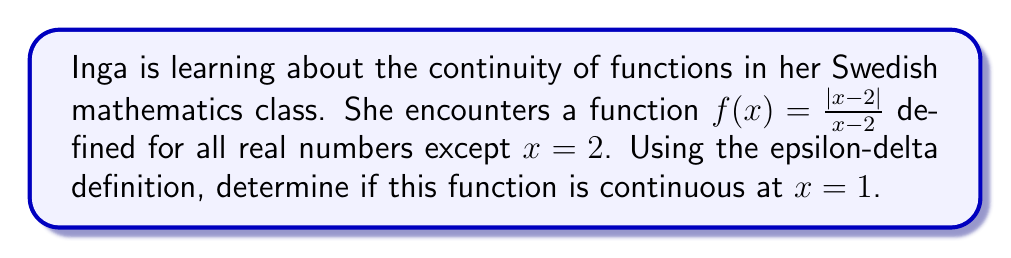What is the answer to this math problem? To prove continuity at $x=1$ using the epsilon-delta definition, we need to show that for every $\epsilon > 0$, there exists a $\delta > 0$ such that:

$|x - 1| < \delta \implies |f(x) - f(1)| < \epsilon$

Let's approach this step-by-step:

1) First, let's calculate $f(1)$:
   $f(1) = \frac{|1-2|}{1-2} = \frac{1}{-1} = -1$

2) Now, let's simplify $|f(x) - f(1)|$:
   $|f(x) - f(1)| = |\frac{|x-2|}{x-2} - (-1)|$
                  $= |\frac{|x-2|}{x-2} + 1|$

3) For $x < 2$, $|x-2| = -(x-2)$, so:
   $|\frac{|x-2|}{x-2} + 1| = |\frac{-(x-2)}{x-2} + 1| = |(-1) + 1| = 0$

4) This means that for all $x < 2$, $f(x) = -1 = f(1)$

5) Therefore, for any $\epsilon > 0$, we can choose any $\delta > 0$ such that $\delta < 1$ (to ensure $x < 2$), and we will have:

   $|x - 1| < \delta \implies |f(x) - f(1)| = 0 < \epsilon$

This satisfies the epsilon-delta definition of continuity at $x=1$.
Answer: The function $f(x) = \frac{|x-2|}{x-2}$ is continuous at $x=1$. 